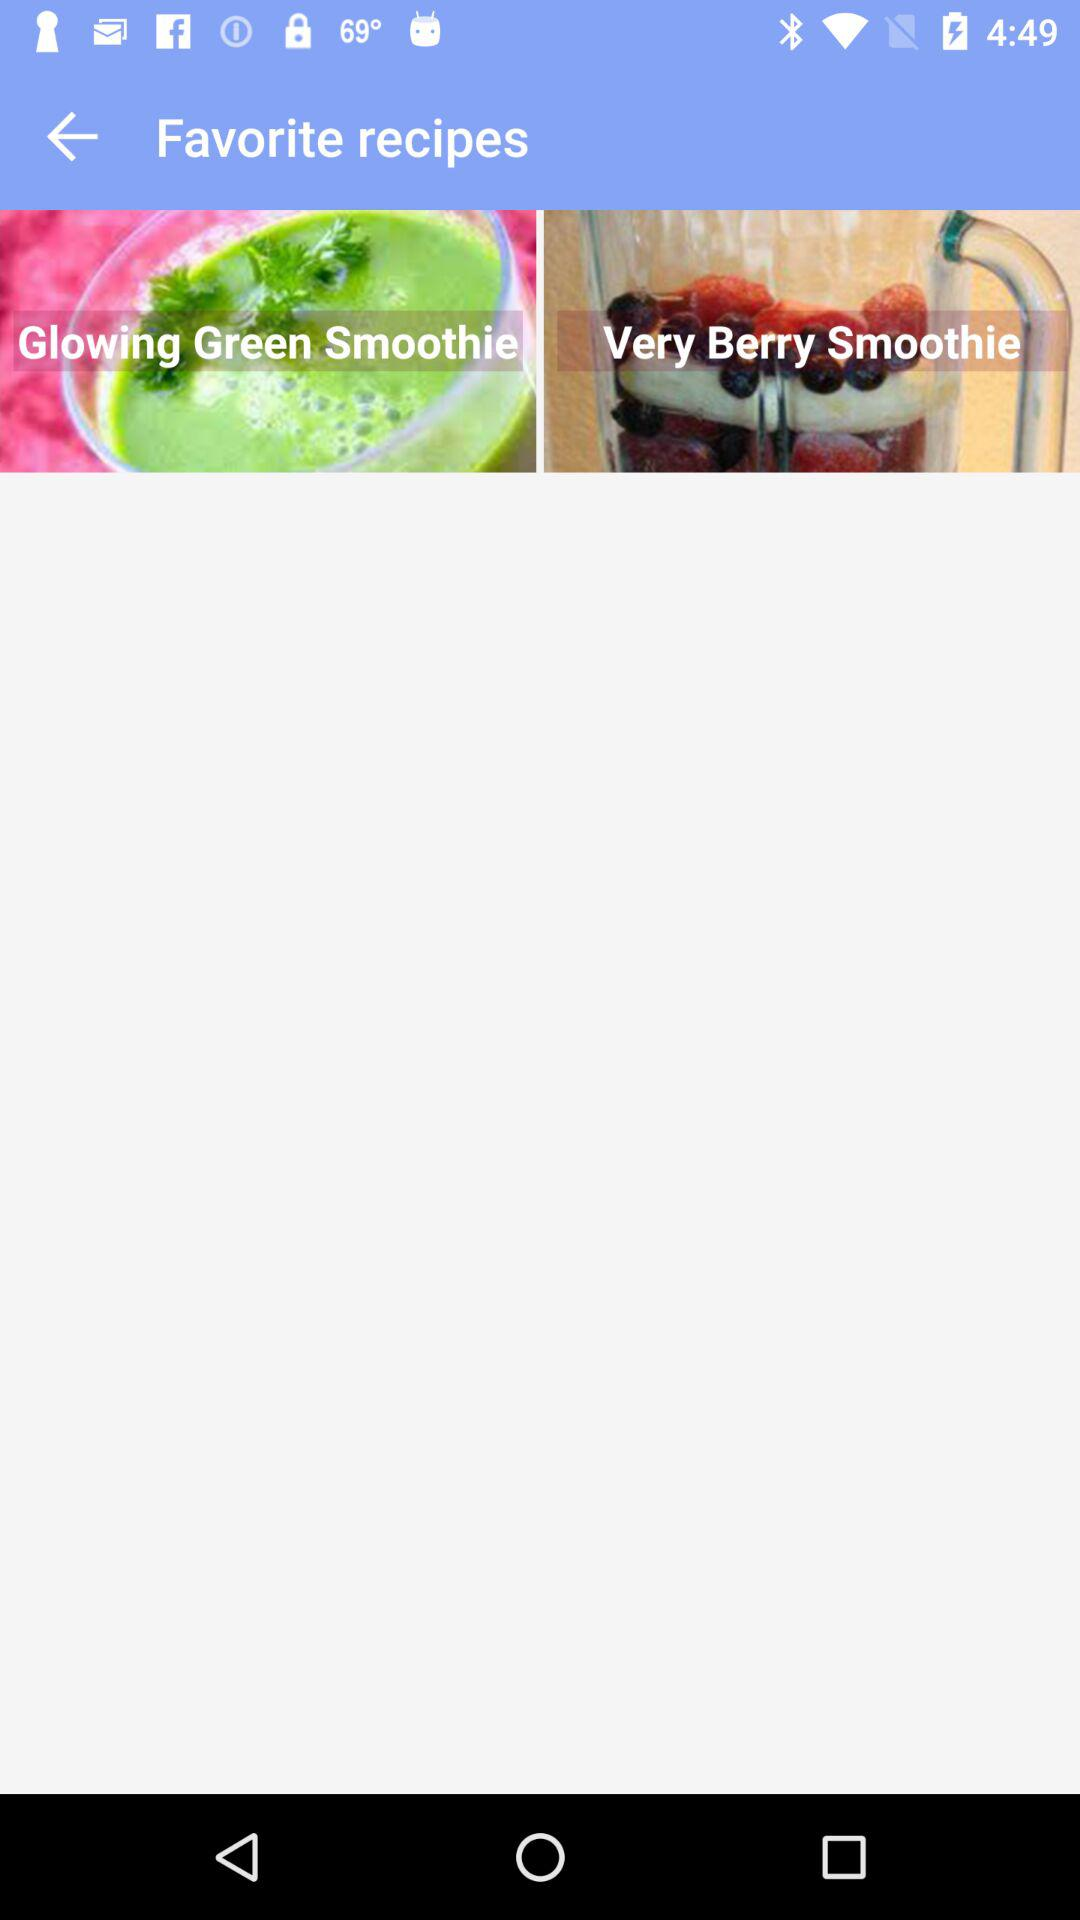How many recipes are in my favorites?
Answer the question using a single word or phrase. 2 